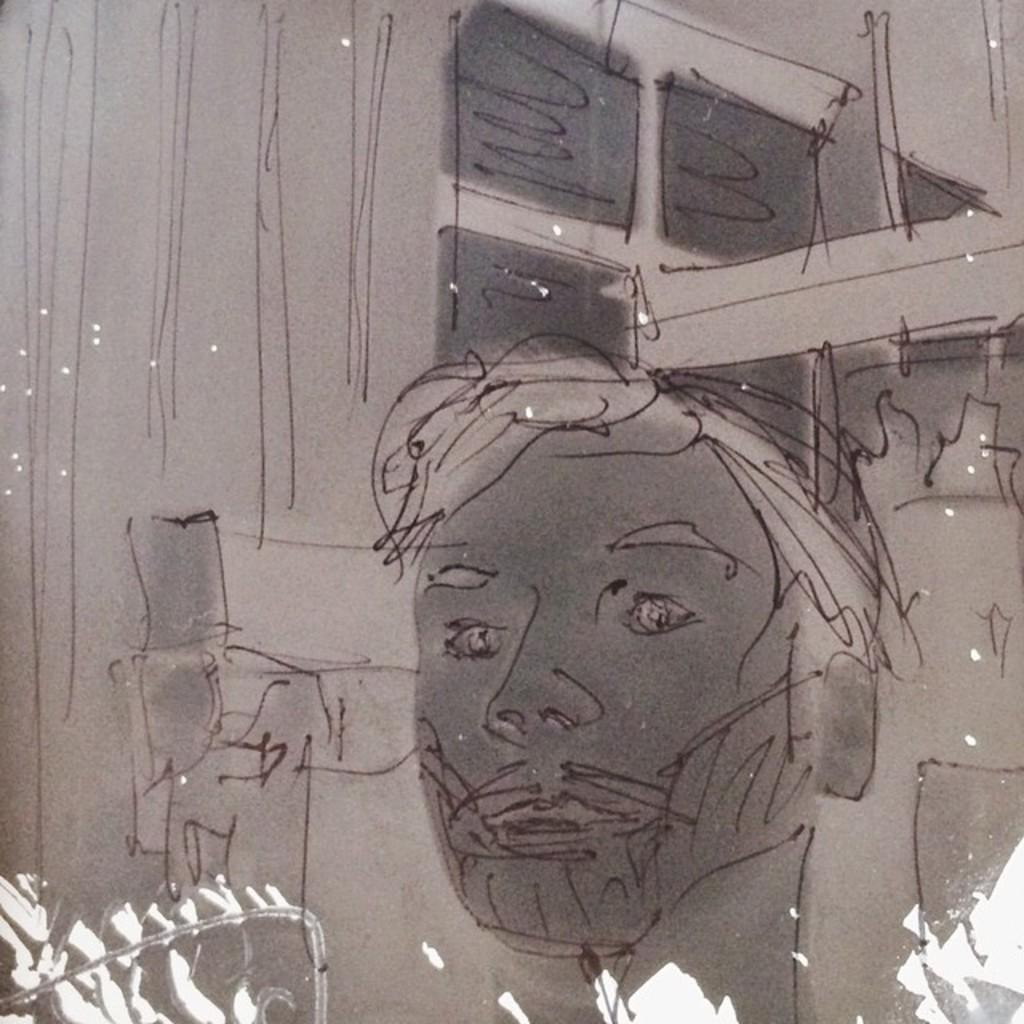What is the main subject of the image? There is a drawing in the image. Can you describe the drawing? Unfortunately, the facts provided do not give any details about the drawing itself. What can be seen at the bottom of the image? There is light visible at the bottom of the image. What type of anger is being expressed by the shelf in the image? There is no shelf present in the image, and therefore no expression of anger can be observed. 